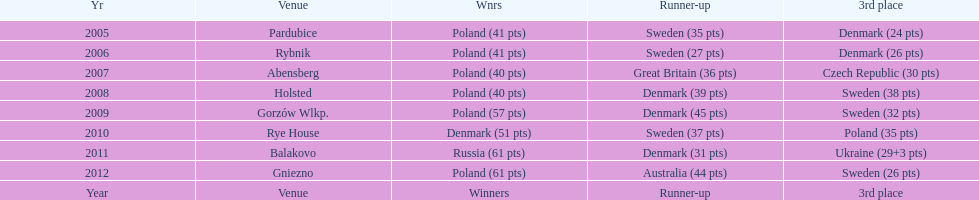Could you parse the entire table as a dict? {'header': ['Yr', 'Venue', 'Wnrs', 'Runner-up', '3rd place'], 'rows': [['2005', 'Pardubice', 'Poland (41 pts)', 'Sweden (35 pts)', 'Denmark (24 pts)'], ['2006', 'Rybnik', 'Poland (41 pts)', 'Sweden (27 pts)', 'Denmark (26 pts)'], ['2007', 'Abensberg', 'Poland (40 pts)', 'Great Britain (36 pts)', 'Czech Republic (30 pts)'], ['2008', 'Holsted', 'Poland (40 pts)', 'Denmark (39 pts)', 'Sweden (38 pts)'], ['2009', 'Gorzów Wlkp.', 'Poland (57 pts)', 'Denmark (45 pts)', 'Sweden (32 pts)'], ['2010', 'Rye House', 'Denmark (51 pts)', 'Sweden (37 pts)', 'Poland (35 pts)'], ['2011', 'Balakovo', 'Russia (61 pts)', 'Denmark (31 pts)', 'Ukraine (29+3 pts)'], ['2012', 'Gniezno', 'Poland (61 pts)', 'Australia (44 pts)', 'Sweden (26 pts)'], ['Year', 'Venue', 'Winners', 'Runner-up', '3rd place']]} What was the ultimate year that a 3rd place finish resulted in less than 25 points? 2005. 